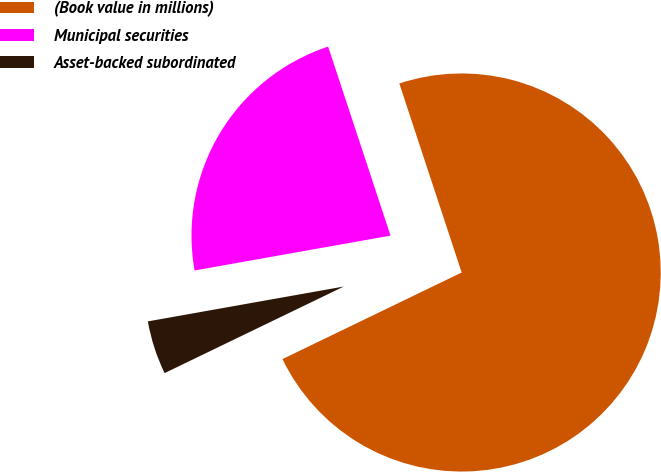Convert chart to OTSL. <chart><loc_0><loc_0><loc_500><loc_500><pie_chart><fcel>(Book value in millions)<fcel>Municipal securities<fcel>Asset-backed subordinated<nl><fcel>72.91%<fcel>22.73%<fcel>4.36%<nl></chart> 